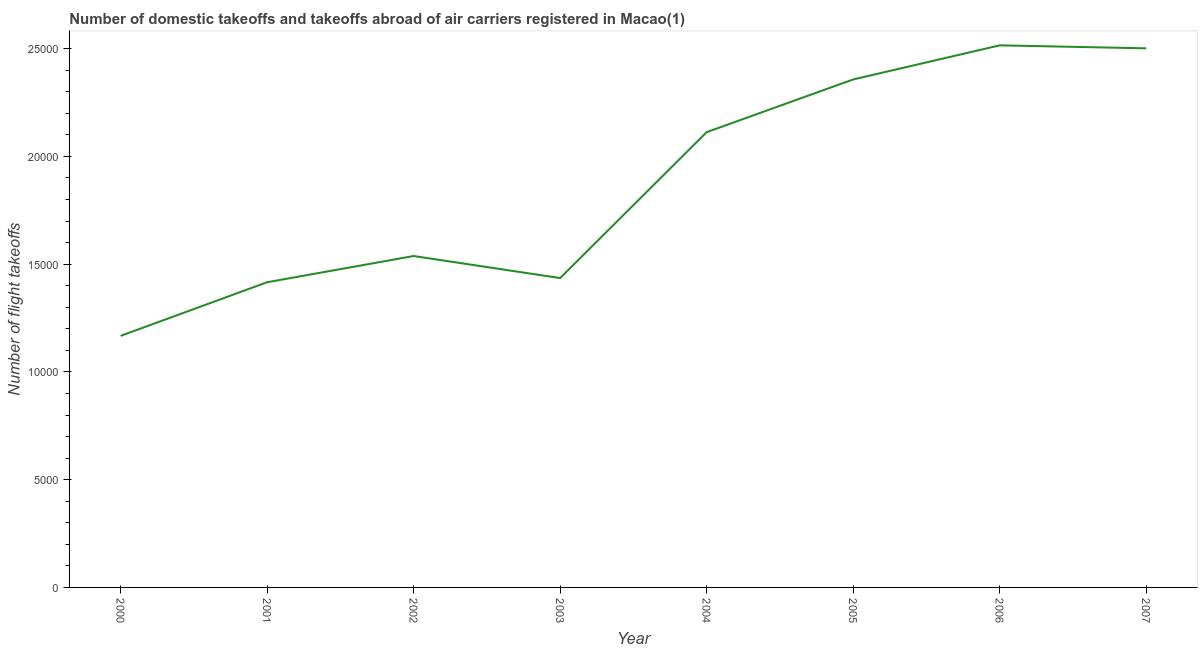What is the number of flight takeoffs in 2003?
Offer a very short reply. 1.44e+04. Across all years, what is the maximum number of flight takeoffs?
Your answer should be very brief. 2.52e+04. Across all years, what is the minimum number of flight takeoffs?
Make the answer very short. 1.17e+04. What is the sum of the number of flight takeoffs?
Offer a terse response. 1.50e+05. What is the difference between the number of flight takeoffs in 2001 and 2003?
Your answer should be compact. -194. What is the average number of flight takeoffs per year?
Offer a terse response. 1.88e+04. What is the median number of flight takeoffs?
Keep it short and to the point. 1.83e+04. In how many years, is the number of flight takeoffs greater than 11000 ?
Offer a terse response. 8. Do a majority of the years between 2000 and 2005 (inclusive) have number of flight takeoffs greater than 4000 ?
Ensure brevity in your answer.  Yes. What is the ratio of the number of flight takeoffs in 2002 to that in 2004?
Offer a terse response. 0.73. What is the difference between the highest and the second highest number of flight takeoffs?
Your response must be concise. 138. Is the sum of the number of flight takeoffs in 2002 and 2004 greater than the maximum number of flight takeoffs across all years?
Your answer should be compact. Yes. What is the difference between the highest and the lowest number of flight takeoffs?
Give a very brief answer. 1.35e+04. How many years are there in the graph?
Your answer should be compact. 8. What is the difference between two consecutive major ticks on the Y-axis?
Provide a short and direct response. 5000. Does the graph contain grids?
Make the answer very short. No. What is the title of the graph?
Make the answer very short. Number of domestic takeoffs and takeoffs abroad of air carriers registered in Macao(1). What is the label or title of the X-axis?
Your answer should be very brief. Year. What is the label or title of the Y-axis?
Offer a very short reply. Number of flight takeoffs. What is the Number of flight takeoffs of 2000?
Give a very brief answer. 1.17e+04. What is the Number of flight takeoffs of 2001?
Provide a succinct answer. 1.42e+04. What is the Number of flight takeoffs in 2002?
Ensure brevity in your answer.  1.54e+04. What is the Number of flight takeoffs of 2003?
Provide a short and direct response. 1.44e+04. What is the Number of flight takeoffs of 2004?
Make the answer very short. 2.11e+04. What is the Number of flight takeoffs of 2005?
Offer a terse response. 2.36e+04. What is the Number of flight takeoffs of 2006?
Ensure brevity in your answer.  2.52e+04. What is the Number of flight takeoffs in 2007?
Provide a short and direct response. 2.50e+04. What is the difference between the Number of flight takeoffs in 2000 and 2001?
Your answer should be very brief. -2488. What is the difference between the Number of flight takeoffs in 2000 and 2002?
Keep it short and to the point. -3705. What is the difference between the Number of flight takeoffs in 2000 and 2003?
Make the answer very short. -2682. What is the difference between the Number of flight takeoffs in 2000 and 2004?
Offer a terse response. -9453. What is the difference between the Number of flight takeoffs in 2000 and 2005?
Ensure brevity in your answer.  -1.19e+04. What is the difference between the Number of flight takeoffs in 2000 and 2006?
Keep it short and to the point. -1.35e+04. What is the difference between the Number of flight takeoffs in 2000 and 2007?
Offer a terse response. -1.33e+04. What is the difference between the Number of flight takeoffs in 2001 and 2002?
Your answer should be very brief. -1217. What is the difference between the Number of flight takeoffs in 2001 and 2003?
Your answer should be compact. -194. What is the difference between the Number of flight takeoffs in 2001 and 2004?
Provide a short and direct response. -6965. What is the difference between the Number of flight takeoffs in 2001 and 2005?
Your answer should be compact. -9411. What is the difference between the Number of flight takeoffs in 2001 and 2006?
Keep it short and to the point. -1.10e+04. What is the difference between the Number of flight takeoffs in 2001 and 2007?
Provide a succinct answer. -1.09e+04. What is the difference between the Number of flight takeoffs in 2002 and 2003?
Provide a succinct answer. 1023. What is the difference between the Number of flight takeoffs in 2002 and 2004?
Make the answer very short. -5748. What is the difference between the Number of flight takeoffs in 2002 and 2005?
Offer a very short reply. -8194. What is the difference between the Number of flight takeoffs in 2002 and 2006?
Your response must be concise. -9776. What is the difference between the Number of flight takeoffs in 2002 and 2007?
Your answer should be compact. -9638. What is the difference between the Number of flight takeoffs in 2003 and 2004?
Provide a succinct answer. -6771. What is the difference between the Number of flight takeoffs in 2003 and 2005?
Your answer should be compact. -9217. What is the difference between the Number of flight takeoffs in 2003 and 2006?
Your answer should be compact. -1.08e+04. What is the difference between the Number of flight takeoffs in 2003 and 2007?
Provide a succinct answer. -1.07e+04. What is the difference between the Number of flight takeoffs in 2004 and 2005?
Keep it short and to the point. -2446. What is the difference between the Number of flight takeoffs in 2004 and 2006?
Offer a very short reply. -4028. What is the difference between the Number of flight takeoffs in 2004 and 2007?
Your answer should be compact. -3890. What is the difference between the Number of flight takeoffs in 2005 and 2006?
Make the answer very short. -1582. What is the difference between the Number of flight takeoffs in 2005 and 2007?
Your answer should be compact. -1444. What is the difference between the Number of flight takeoffs in 2006 and 2007?
Your response must be concise. 138. What is the ratio of the Number of flight takeoffs in 2000 to that in 2001?
Provide a short and direct response. 0.82. What is the ratio of the Number of flight takeoffs in 2000 to that in 2002?
Your response must be concise. 0.76. What is the ratio of the Number of flight takeoffs in 2000 to that in 2003?
Give a very brief answer. 0.81. What is the ratio of the Number of flight takeoffs in 2000 to that in 2004?
Your response must be concise. 0.55. What is the ratio of the Number of flight takeoffs in 2000 to that in 2005?
Your response must be concise. 0.49. What is the ratio of the Number of flight takeoffs in 2000 to that in 2006?
Make the answer very short. 0.46. What is the ratio of the Number of flight takeoffs in 2000 to that in 2007?
Offer a very short reply. 0.47. What is the ratio of the Number of flight takeoffs in 2001 to that in 2002?
Your answer should be very brief. 0.92. What is the ratio of the Number of flight takeoffs in 2001 to that in 2004?
Make the answer very short. 0.67. What is the ratio of the Number of flight takeoffs in 2001 to that in 2005?
Offer a very short reply. 0.6. What is the ratio of the Number of flight takeoffs in 2001 to that in 2006?
Ensure brevity in your answer.  0.56. What is the ratio of the Number of flight takeoffs in 2001 to that in 2007?
Your answer should be very brief. 0.57. What is the ratio of the Number of flight takeoffs in 2002 to that in 2003?
Provide a succinct answer. 1.07. What is the ratio of the Number of flight takeoffs in 2002 to that in 2004?
Give a very brief answer. 0.73. What is the ratio of the Number of flight takeoffs in 2002 to that in 2005?
Ensure brevity in your answer.  0.65. What is the ratio of the Number of flight takeoffs in 2002 to that in 2006?
Your answer should be compact. 0.61. What is the ratio of the Number of flight takeoffs in 2002 to that in 2007?
Your response must be concise. 0.61. What is the ratio of the Number of flight takeoffs in 2003 to that in 2004?
Provide a short and direct response. 0.68. What is the ratio of the Number of flight takeoffs in 2003 to that in 2005?
Give a very brief answer. 0.61. What is the ratio of the Number of flight takeoffs in 2003 to that in 2006?
Give a very brief answer. 0.57. What is the ratio of the Number of flight takeoffs in 2003 to that in 2007?
Provide a short and direct response. 0.57. What is the ratio of the Number of flight takeoffs in 2004 to that in 2005?
Provide a succinct answer. 0.9. What is the ratio of the Number of flight takeoffs in 2004 to that in 2006?
Your answer should be compact. 0.84. What is the ratio of the Number of flight takeoffs in 2004 to that in 2007?
Give a very brief answer. 0.84. What is the ratio of the Number of flight takeoffs in 2005 to that in 2006?
Give a very brief answer. 0.94. What is the ratio of the Number of flight takeoffs in 2005 to that in 2007?
Offer a terse response. 0.94. What is the ratio of the Number of flight takeoffs in 2006 to that in 2007?
Your response must be concise. 1.01. 